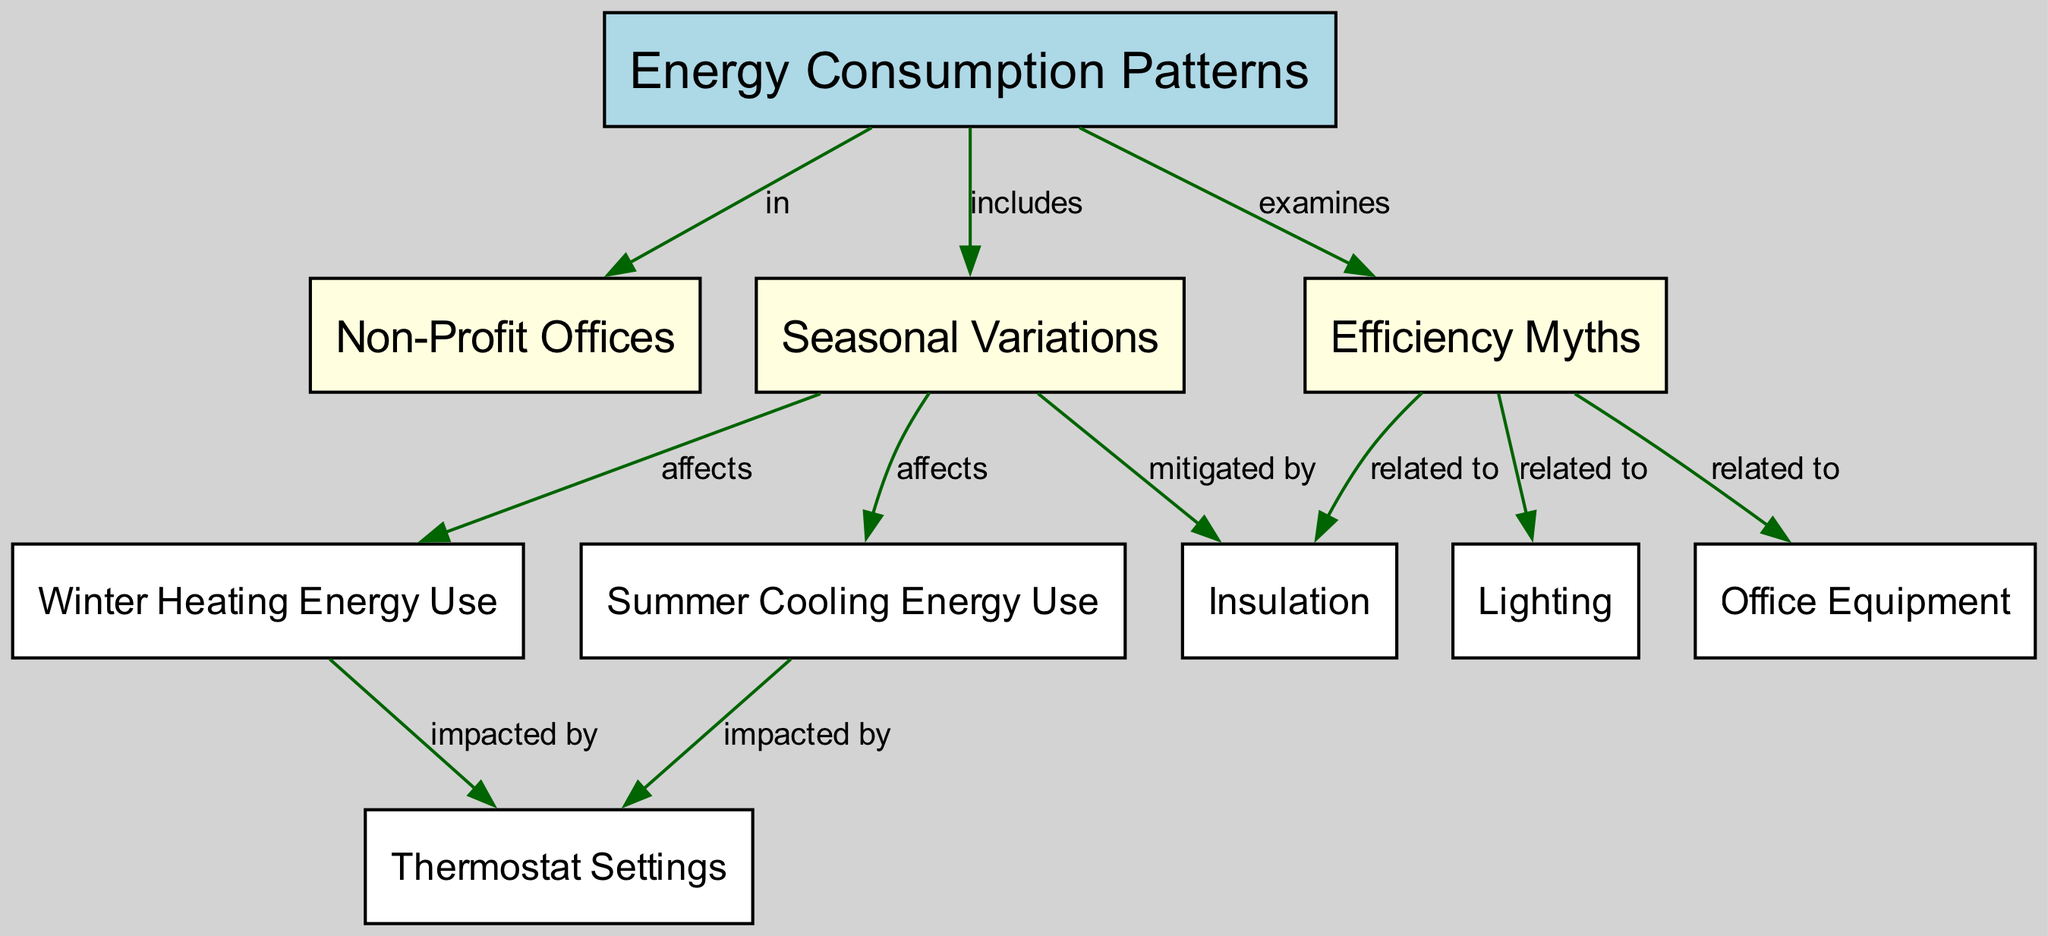What node examines efficiency myths? The node labeled "Efficiency Myths" is connected to the main node "Energy Consumption Patterns" with the edge labeled "examines." This indicates that "Efficiency Myths" is being explored or analyzed as part of the energy consumption patterns.
Answer: Efficiency Myths How many nodes are present in the diagram? By counting the nodes listed in the diagram, there are a total of 10 nodes connected to various concepts.
Answer: 10 Which nodes are affected by seasonal variations? The nodes "Winter Heating Energy Use" and "Summer Cooling Energy Use" directly connect to "Seasonal Variations," indicating they are influenced by seasonal changes.
Answer: Winter Heating Energy Use and Summer Cooling Energy Use What is mitigated by insulation? The edge labeled "mitigated by" connects "Seasonal Variations" to "Insulation," suggesting that insulation helps reduce the impact of seasonal changes on energy consumption.
Answer: Insulation Which two types of energy use are impacted by thermostat settings? The diagram shows that both "Winter Heating Energy Use" and "Summer Cooling Energy Use" have edges connecting to "Thermostat Settings." This indicates that thermostat settings influence energy consumption for both types.
Answer: Winter Heating Energy Use and Summer Cooling Energy Use What is related to efficiency myths? The nodes "Lighting," "Office Equipment," and "Insulation" all have connections to "Efficiency Myths," each labeled with "related to," indicating these areas are connected to misconceptions about efficiency.
Answer: Lighting, Office Equipment, and Insulation What are the two primary energy uses mentioned in the context of seasonal variations? The nodes of interest under "Seasonal Variations" are "Winter Heating Energy Use" and "Summer Cooling Energy Use," which represent major energy consumption categories affected by seasonal changes.
Answer: Winter Heating Energy Use and Summer Cooling Energy Use 